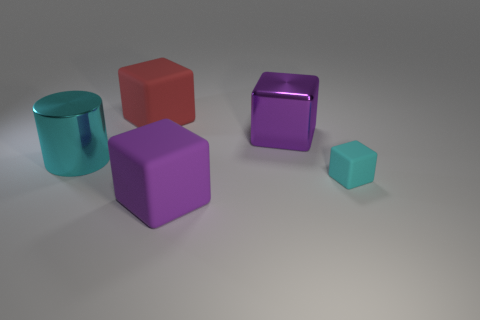There is a cyan thing that is on the left side of the cyan matte cube; is it the same size as the tiny matte cube?
Your response must be concise. No. There is a purple cube that is the same size as the purple matte thing; what is it made of?
Your response must be concise. Metal. Are there any shiny things in front of the big purple thing in front of the cyan object to the left of the purple rubber cube?
Make the answer very short. No. Are there any other things that are the same shape as the cyan matte thing?
Give a very brief answer. Yes. Is the color of the large metal thing to the left of the purple matte object the same as the matte thing that is behind the purple metal object?
Offer a terse response. No. Are any big cyan shiny objects visible?
Your response must be concise. Yes. What is the material of the cube that is the same color as the metallic cylinder?
Make the answer very short. Rubber. There is a rubber block left of the large matte thing that is in front of the large matte block left of the big purple matte cube; how big is it?
Your answer should be compact. Large. Does the tiny cyan rubber thing have the same shape as the shiny thing that is to the right of the large purple rubber block?
Give a very brief answer. Yes. Are there any rubber things that have the same color as the cylinder?
Make the answer very short. Yes. 